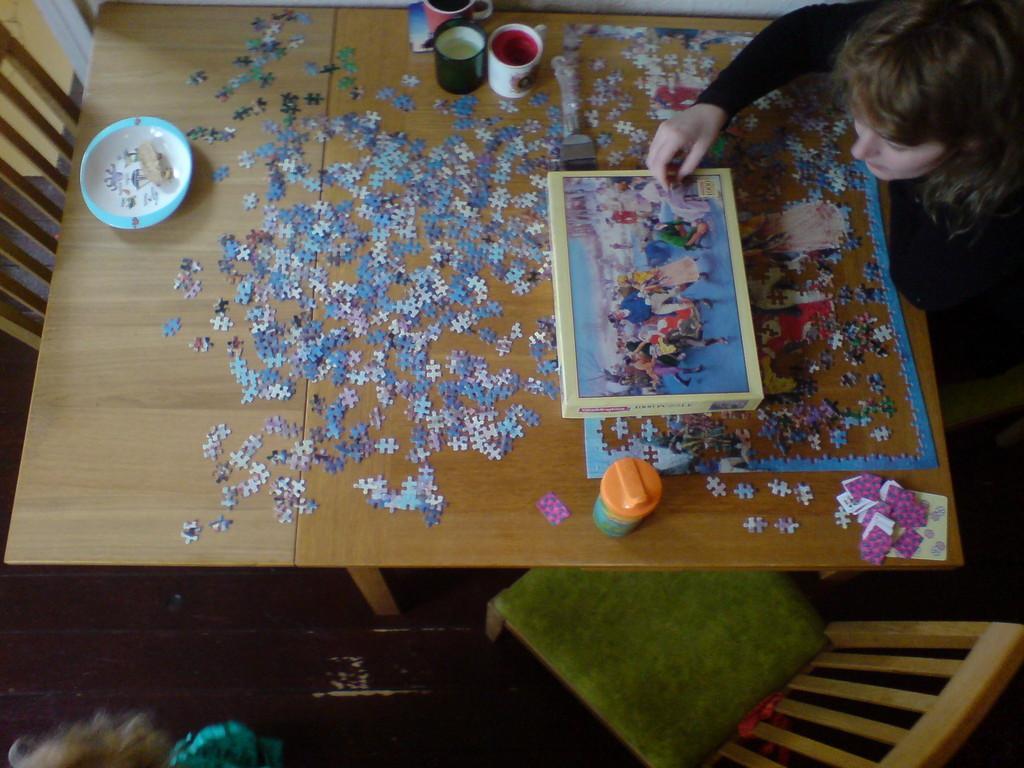Please provide a concise description of this image. In this picture, we see a woman in the black dress is sitting on the chair. In front of her, we see a table on which the cups, plate, puzzle pieces and a glass are placed. I think she is solving the puzzle. At the bottom, we see a chair and the floor. On the left side, we see a chair and behind that, we see a wall. 